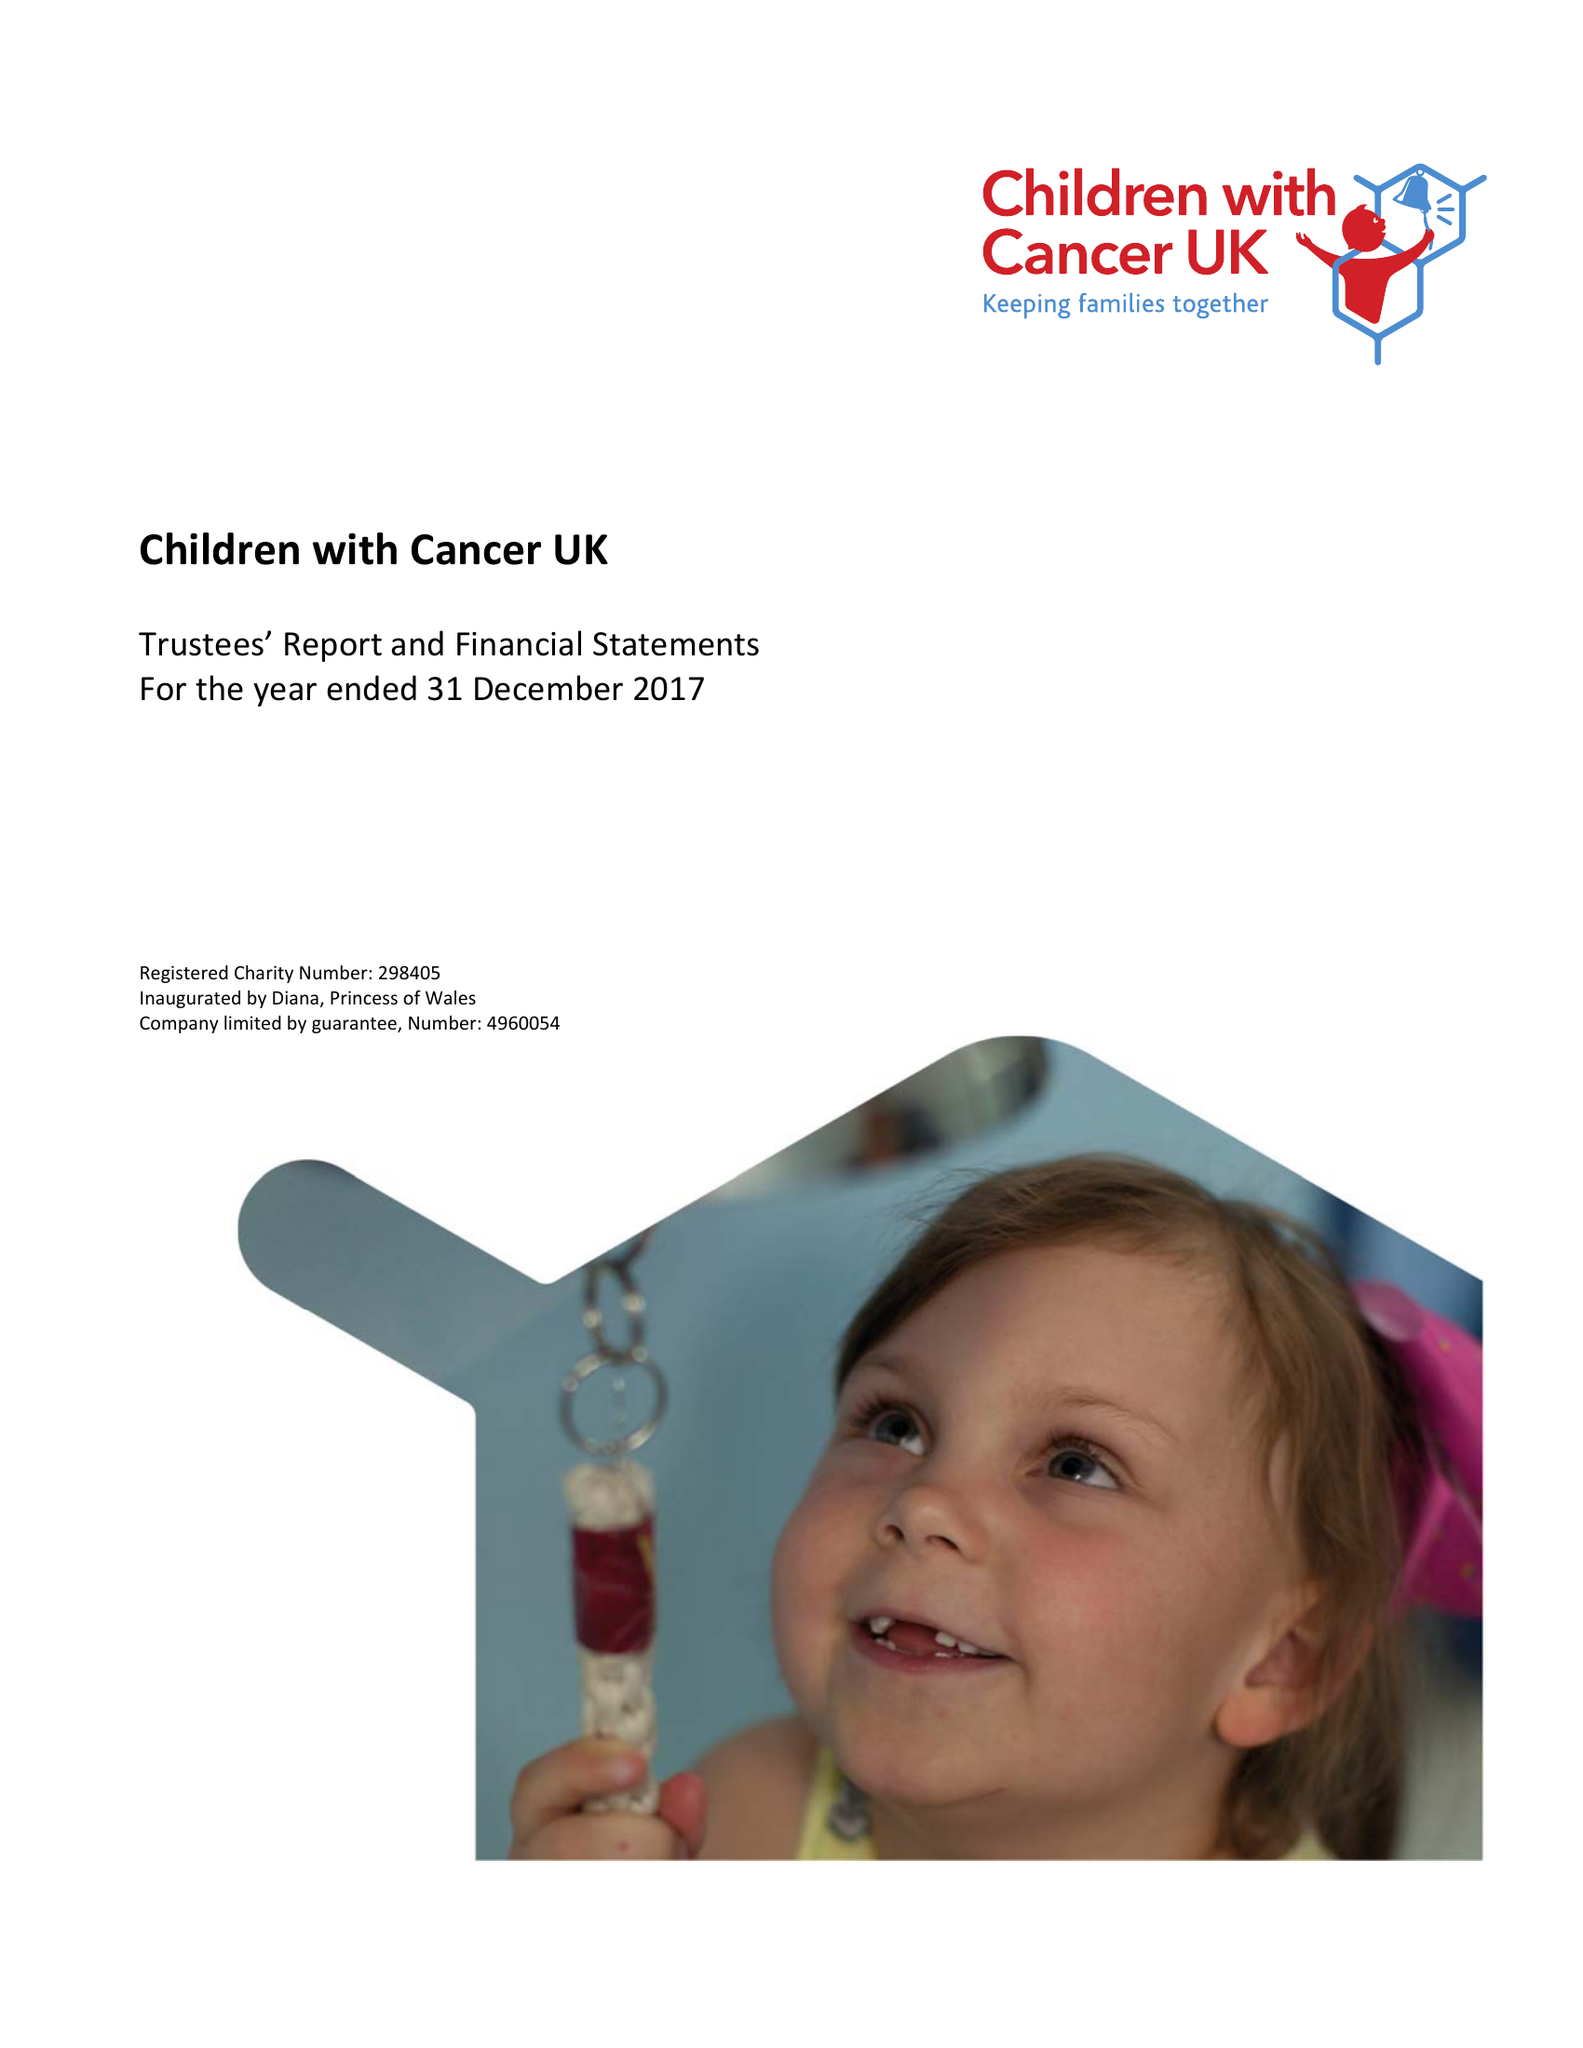What is the value for the spending_annually_in_british_pounds?
Answer the question using a single word or phrase. 15719396.00 